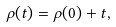Convert formula to latex. <formula><loc_0><loc_0><loc_500><loc_500>\rho ( t ) = \rho ( 0 ) + t ,</formula> 